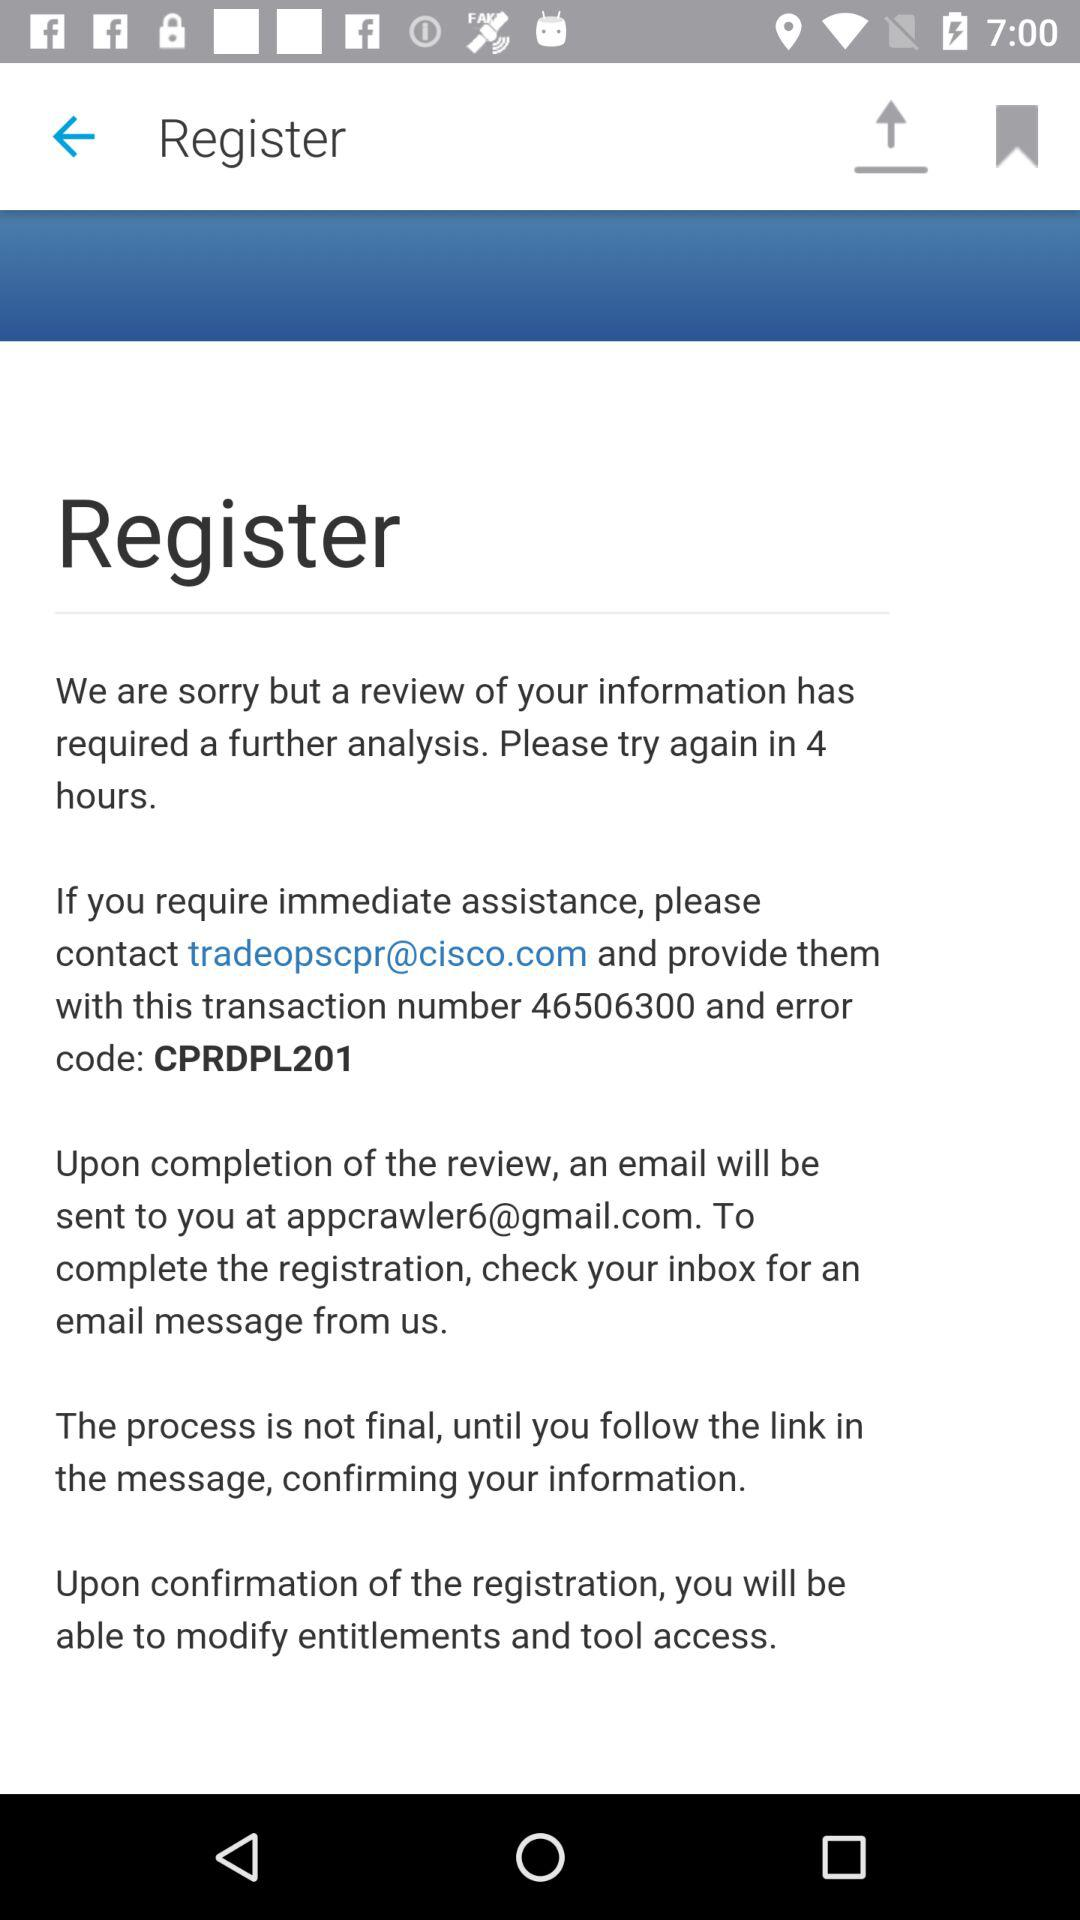How many hours until the user can try again?
Answer the question using a single word or phrase. 4 